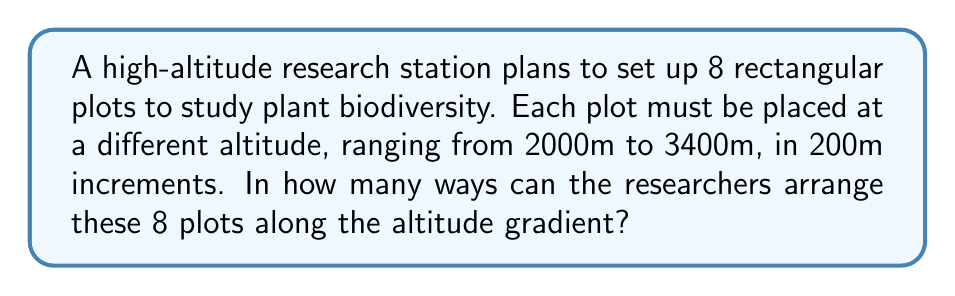Show me your answer to this math problem. Let's approach this step-by-step:

1) We have 8 plots that need to be arranged in a specific order along the altitude gradient. This is a permutation problem.

2) Each plot must be at a different altitude, and there are exactly 8 altitude levels (2000m, 2200m, 2400m, ..., 3400m). This means we need to arrange all 8 plots, with no repetitions.

3) The formula for permutations of n distinct objects is:

   $$P(n) = n!$$

   Where $n!$ represents the factorial of n.

4) In this case, $n = 8$, so we need to calculate $8!$

5) Let's expand this:

   $$8! = 8 \times 7 \times 6 \times 5 \times 4 \times 3 \times 2 \times 1$$

6) Multiplying these numbers:

   $$8! = 40,320$$

Therefore, there are 40,320 ways to arrange the 8 research plots along the altitude gradient.
Answer: $40,320$ 